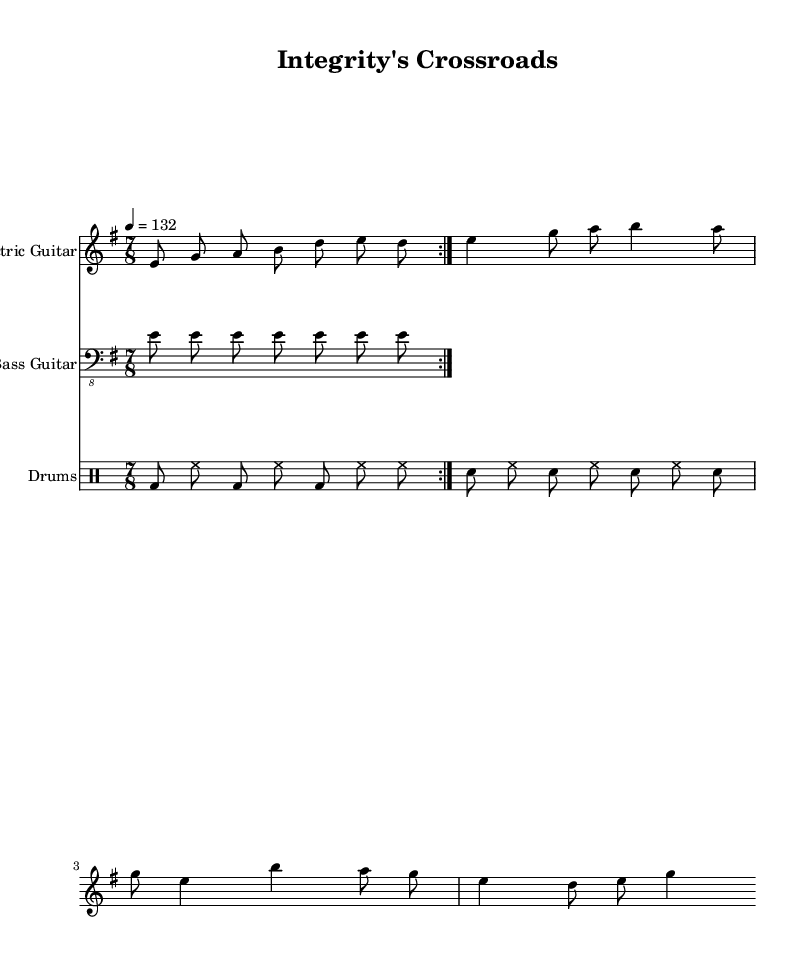What is the key signature of this music? The key signature is E minor, indicated by one sharp (F#) in the key signature at the beginning of the staff.
Answer: E minor What is the time signature of this piece? The time signature is 7/8, which is shown at the beginning of the piece next to the key signature. This indicates that there are seven eighth notes per measure.
Answer: 7/8 What is the tempo marking for this music? The tempo is marked at quarter note equals 132, which is indicated in the tempo notation at the beginning of the score. This tells performers the speed of the piece.
Answer: 132 How many measures are in the main riff for the electric guitar? The main riff is written to be repeated for two measures, as indicated by the 'volta' marking that specifies the repetition.
Answer: 2 What clef is used for the bass guitar staff? The clef for the bass guitar is the bass clef, which is indicated at the beginning of the bass guitar staff in the score. This denotes the pitch range for bass instruments.
Answer: Bass clef How many different drum patterns are present in the drum section? The drum section features two distinct drum patterns within the provided measures: a kick-snare pattern and a hi-hat pattern. Both patterns play different parts across the measures.
Answer: 2 What type of texture is created by the multiple instruments in this piece? The piece exhibits a polyphonic texture, as it consists of multiple independent melodies being played simultaneously, particularly the interaction between electric guitar, bass, and drums.
Answer: Polyphonic 